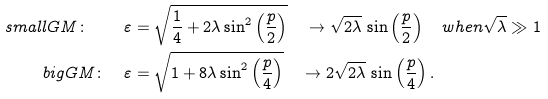Convert formula to latex. <formula><loc_0><loc_0><loc_500><loc_500>s m a l l G M \colon \quad \varepsilon & = \sqrt { \frac { 1 } { 4 } + 2 \lambda \sin ^ { 2 } \left ( \frac { p } { 2 } \right ) } \quad \to \sqrt { 2 \lambda } \, \sin \left ( \frac { p } { 2 } \right ) \quad w h e n \sqrt { \lambda } \gg 1 \\ b i g G M \colon \quad \varepsilon & = \sqrt { 1 + 8 \lambda \sin ^ { 2 } \left ( \frac { p } { 4 } \right ) } \quad \to 2 \sqrt { 2 \lambda } \, \sin \left ( \frac { p } { 4 } \right ) .</formula> 